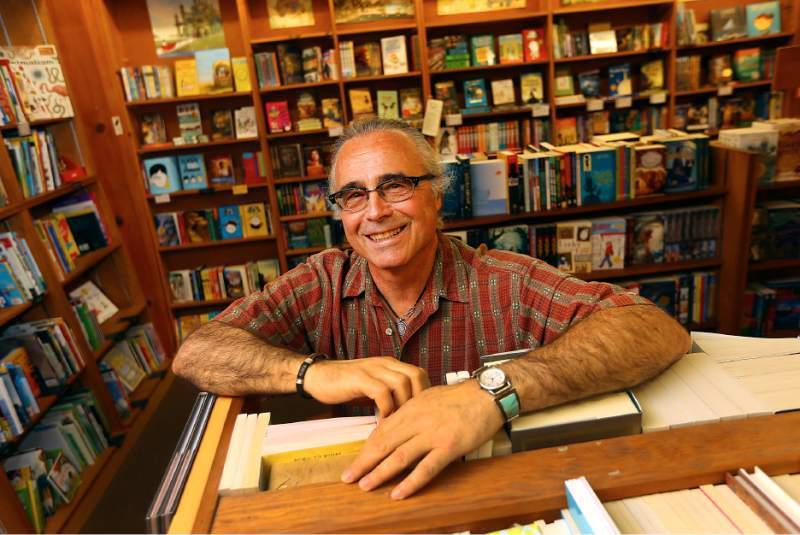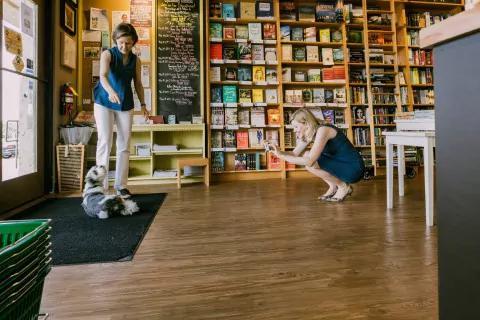The first image is the image on the left, the second image is the image on the right. Examine the images to the left and right. Is the description "One image shows a red-headed woman in a reddish dress sitting in front of open boxes of books." accurate? Answer yes or no. No. The first image is the image on the left, the second image is the image on the right. Given the left and right images, does the statement "A woman in a red blouse is sitting at a table of books in one of the images." hold true? Answer yes or no. No. 